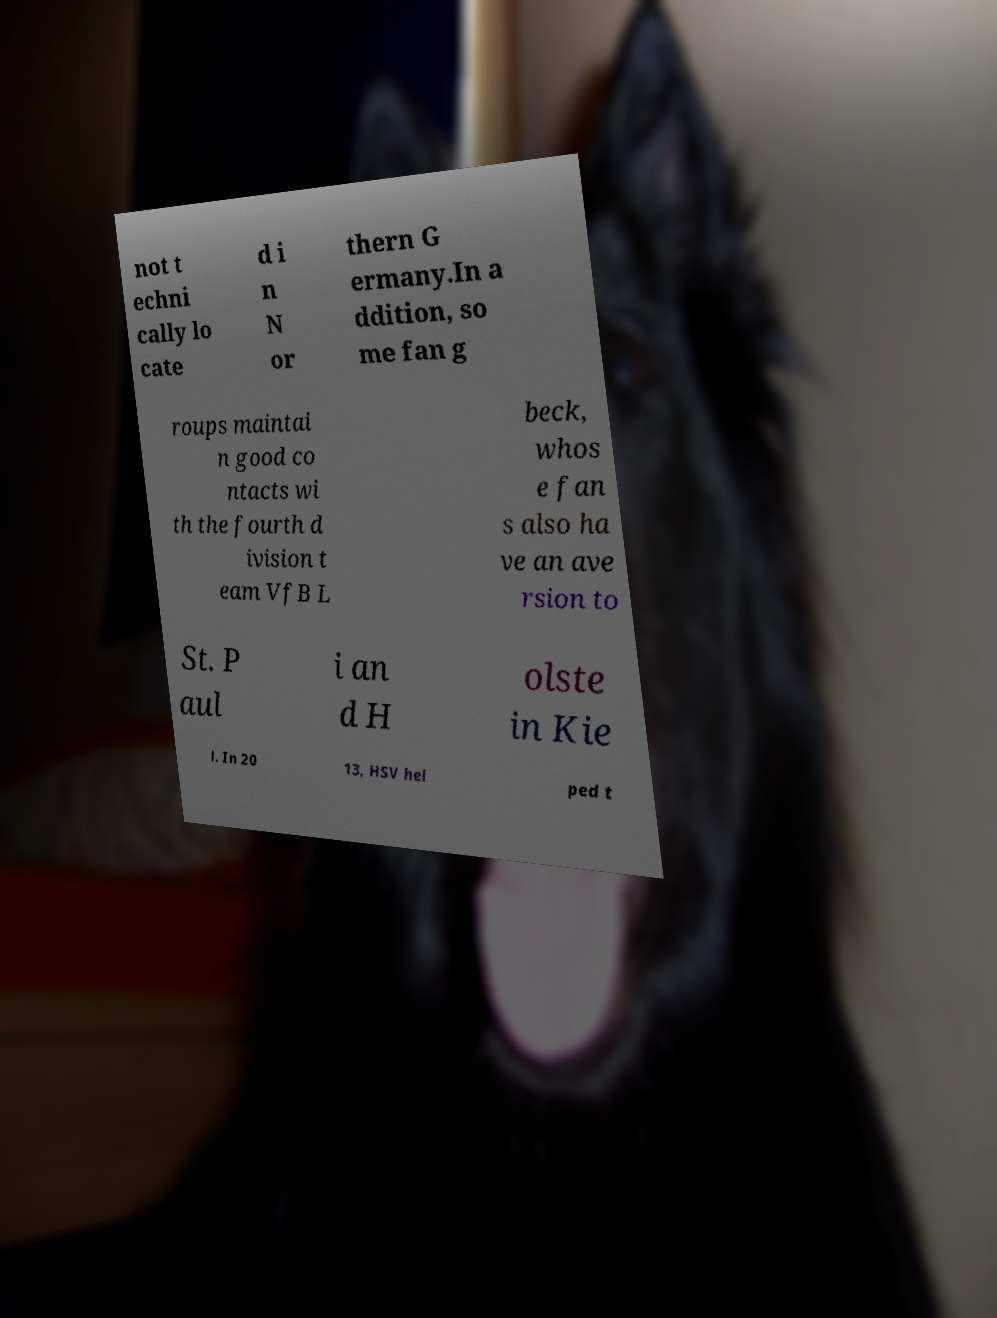There's text embedded in this image that I need extracted. Can you transcribe it verbatim? not t echni cally lo cate d i n N or thern G ermany.In a ddition, so me fan g roups maintai n good co ntacts wi th the fourth d ivision t eam VfB L beck, whos e fan s also ha ve an ave rsion to St. P aul i an d H olste in Kie l. In 20 13, HSV hel ped t 